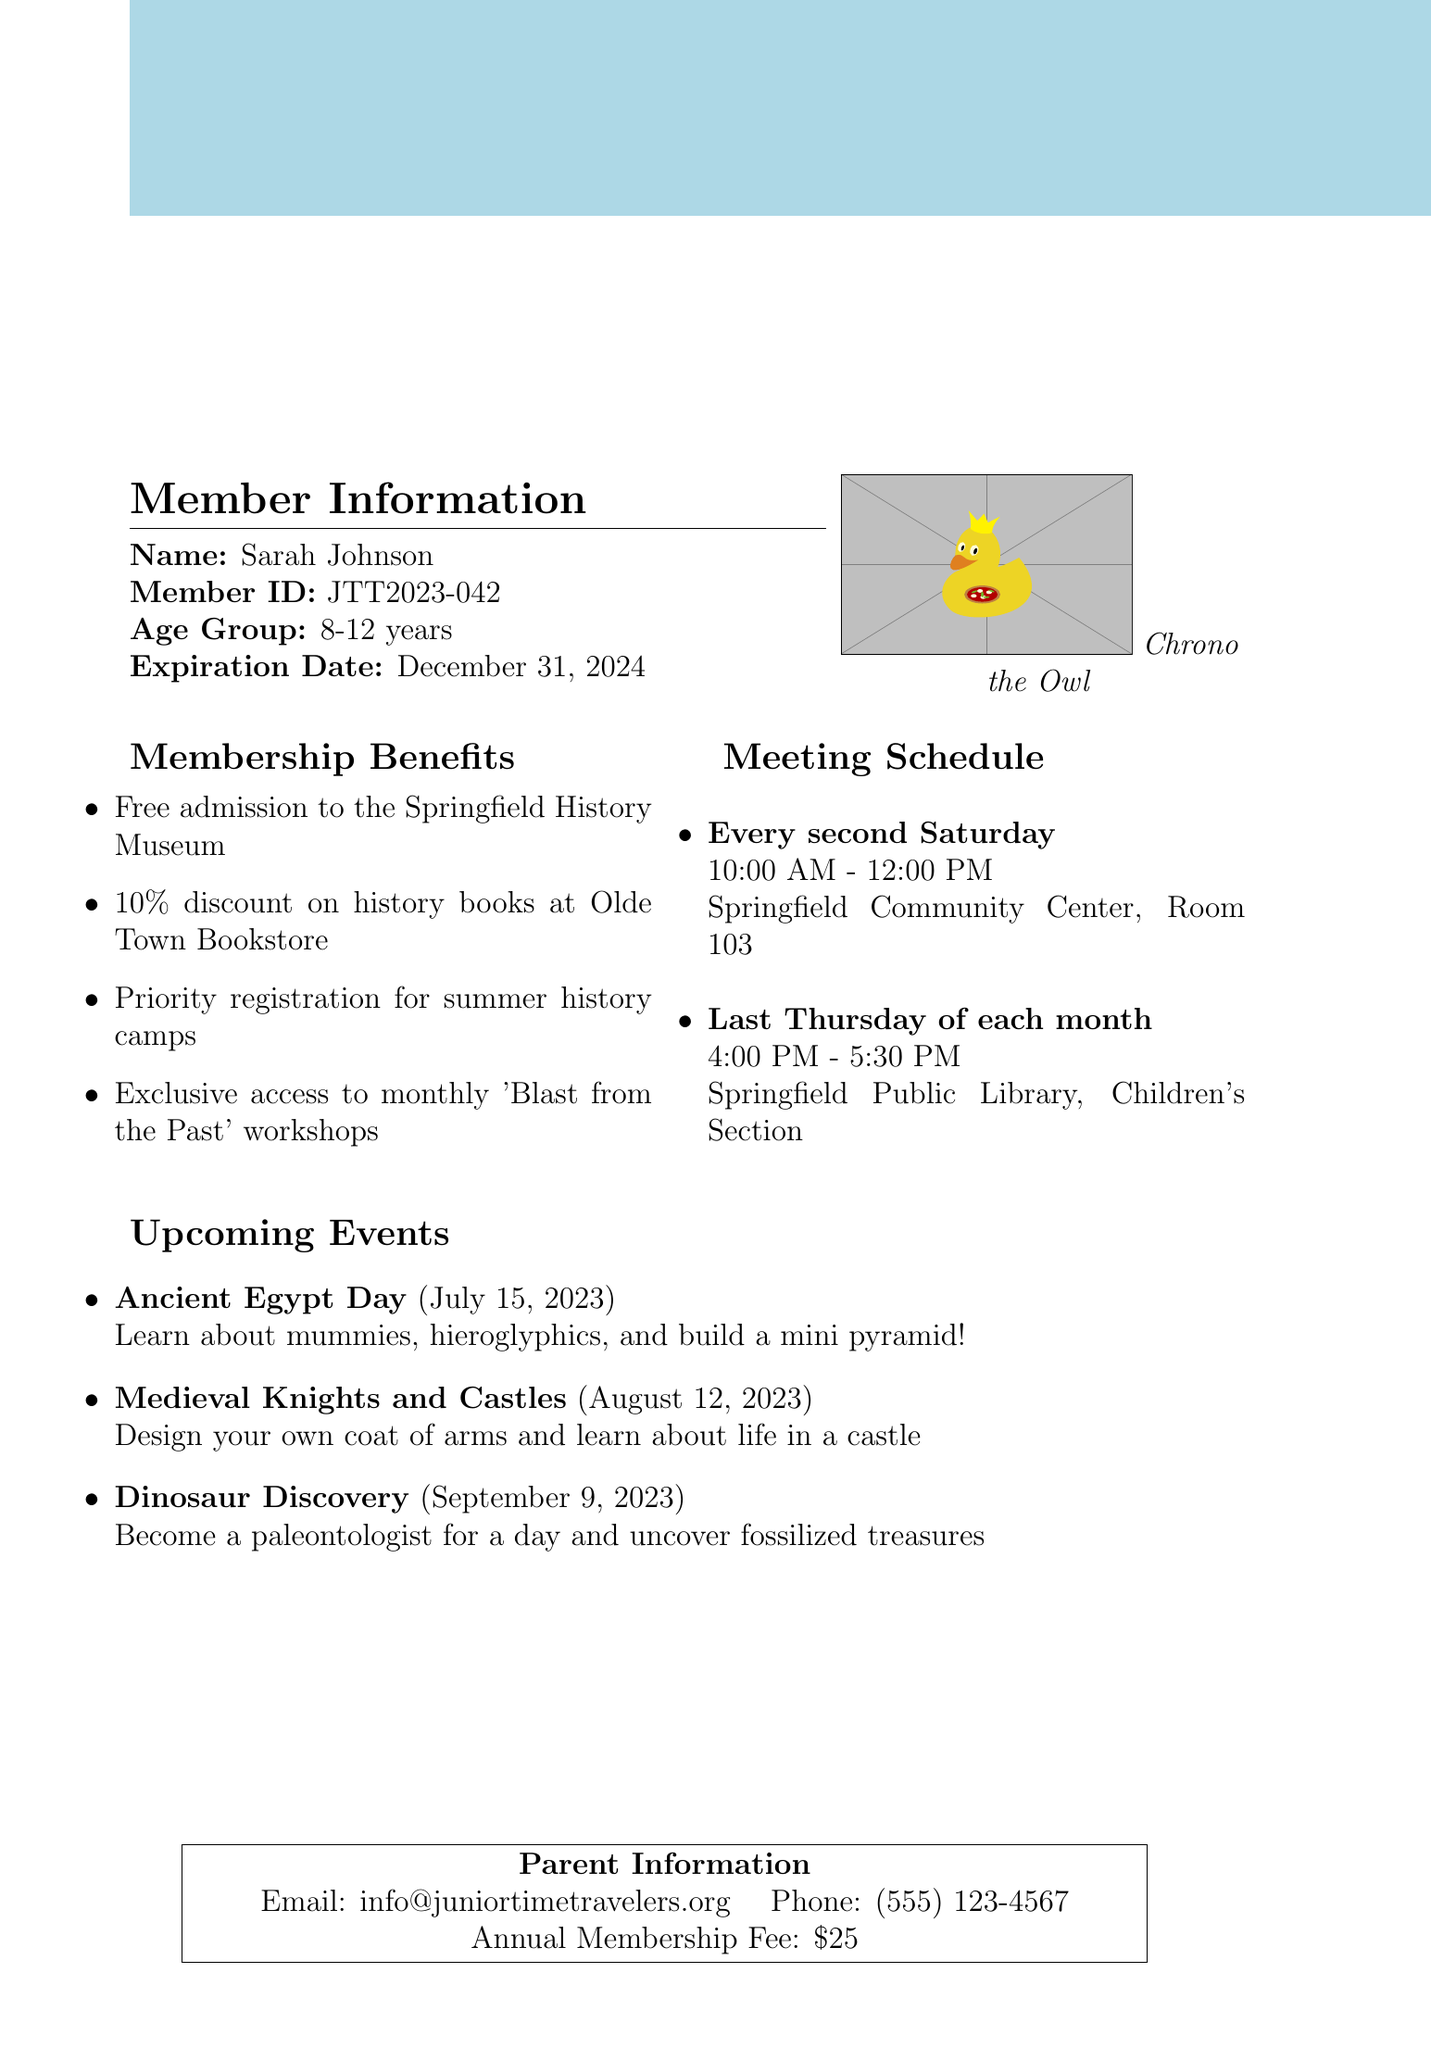What is the name of the club? The name of the club is mentioned in the document as the title.
Answer: Junior Time Travelers Society Who is the member listed on the card? The document specifies the name of the member in the member information section.
Answer: Sarah Johnson What is the member ID? The member ID is explicitly provided in the document under member information.
Answer: JTT2023-042 When does the membership expire? The expiration date is clearly stated in the document.
Answer: December 31, 2024 What is the annual membership fee? The parent information section of the document provides the annual fee amount.
Answer: $25 What is the location of the first meeting? The location of the first scheduled meeting is provided in the meeting schedule section.
Answer: Springfield Community Center, Room 103 How many benefits are listed for members? The number of membership benefits can be counted from the benefits section in the document.
Answer: Four What is the date of the "Dinosaur Discovery" event? The upcoming events section specifies the date of this event.
Answer: September 9, 2023 What type of animal is Chrono? The document describes the club mascot in a specific way.
Answer: Owl 